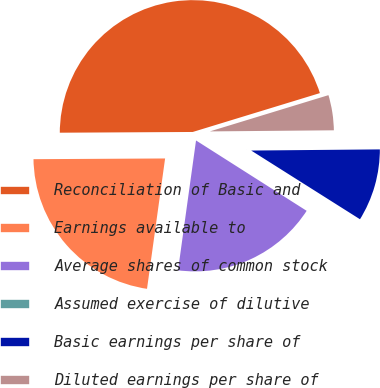<chart> <loc_0><loc_0><loc_500><loc_500><pie_chart><fcel>Reconciliation of Basic and<fcel>Earnings available to<fcel>Average shares of common stock<fcel>Assumed exercise of dilutive<fcel>Basic earnings per share of<fcel>Diluted earnings per share of<nl><fcel>45.37%<fcel>22.72%<fcel>18.18%<fcel>0.05%<fcel>9.11%<fcel>4.58%<nl></chart> 